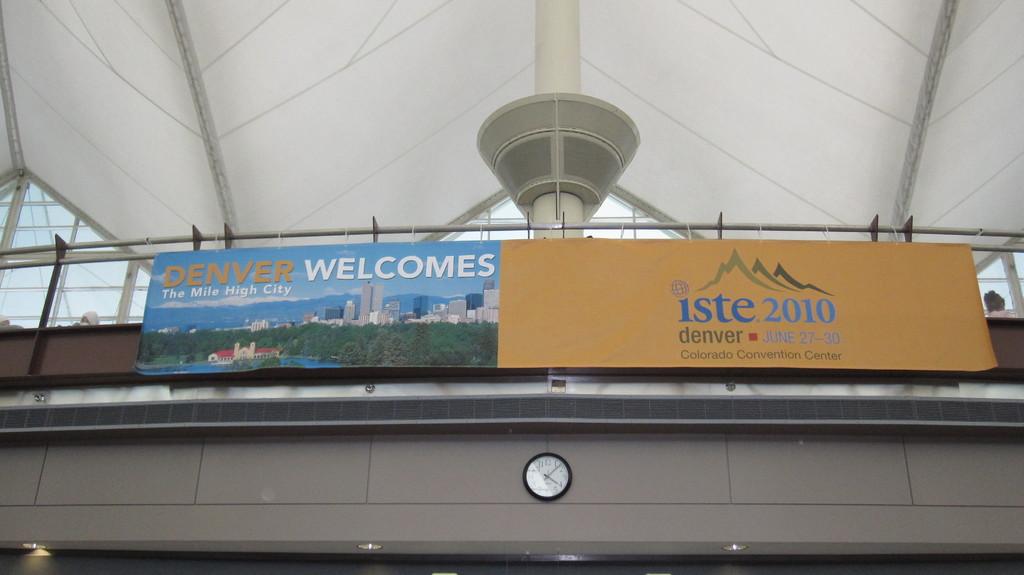What city is on the sign?
Your response must be concise. Denver. What convention is on the brown sign?
Make the answer very short. Iste 2010. 